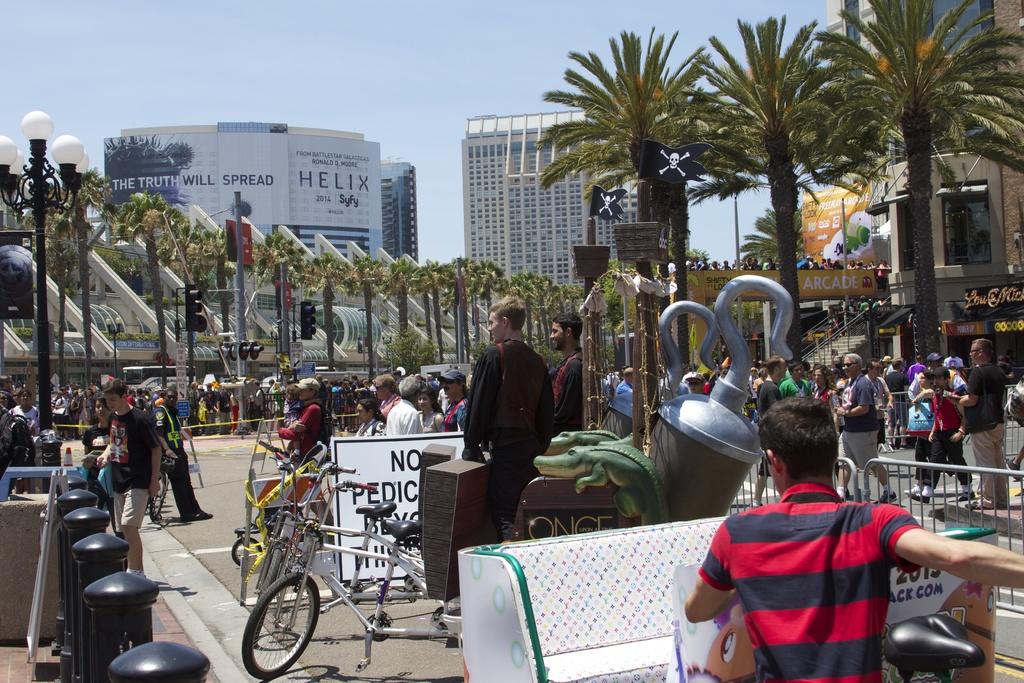Are bikes allowed to ride there ?
Keep it short and to the point. No. What will spread?
Offer a very short reply. The truth. 